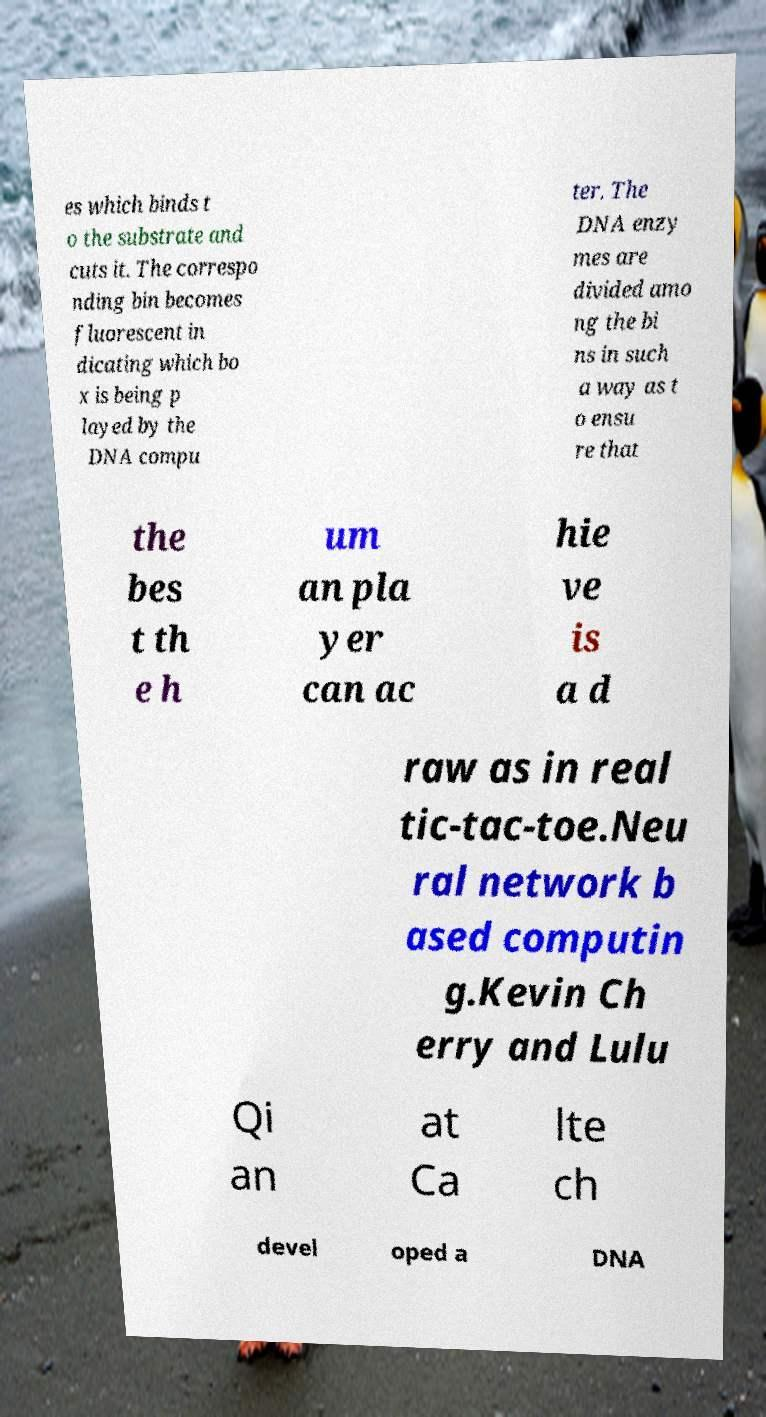Please identify and transcribe the text found in this image. es which binds t o the substrate and cuts it. The correspo nding bin becomes fluorescent in dicating which bo x is being p layed by the DNA compu ter. The DNA enzy mes are divided amo ng the bi ns in such a way as t o ensu re that the bes t th e h um an pla yer can ac hie ve is a d raw as in real tic-tac-toe.Neu ral network b ased computin g.Kevin Ch erry and Lulu Qi an at Ca lte ch devel oped a DNA 